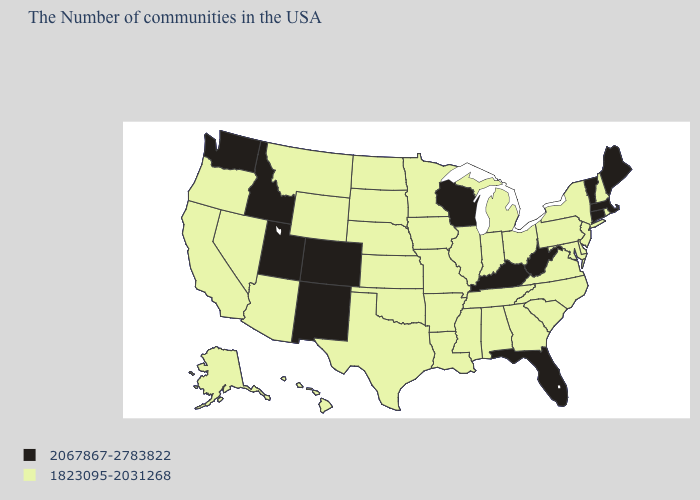What is the lowest value in states that border Washington?
Give a very brief answer. 1823095-2031268. Does Illinois have the same value as Idaho?
Write a very short answer. No. Name the states that have a value in the range 1823095-2031268?
Give a very brief answer. Rhode Island, New Hampshire, New York, New Jersey, Delaware, Maryland, Pennsylvania, Virginia, North Carolina, South Carolina, Ohio, Georgia, Michigan, Indiana, Alabama, Tennessee, Illinois, Mississippi, Louisiana, Missouri, Arkansas, Minnesota, Iowa, Kansas, Nebraska, Oklahoma, Texas, South Dakota, North Dakota, Wyoming, Montana, Arizona, Nevada, California, Oregon, Alaska, Hawaii. What is the value of Florida?
Write a very short answer. 2067867-2783822. How many symbols are there in the legend?
Quick response, please. 2. Name the states that have a value in the range 2067867-2783822?
Short answer required. Maine, Massachusetts, Vermont, Connecticut, West Virginia, Florida, Kentucky, Wisconsin, Colorado, New Mexico, Utah, Idaho, Washington. Does the map have missing data?
Concise answer only. No. Does Ohio have the lowest value in the MidWest?
Concise answer only. Yes. Among the states that border Mississippi , which have the highest value?
Give a very brief answer. Alabama, Tennessee, Louisiana, Arkansas. Among the states that border North Carolina , which have the highest value?
Be succinct. Virginia, South Carolina, Georgia, Tennessee. Name the states that have a value in the range 2067867-2783822?
Write a very short answer. Maine, Massachusetts, Vermont, Connecticut, West Virginia, Florida, Kentucky, Wisconsin, Colorado, New Mexico, Utah, Idaho, Washington. Among the states that border Washington , does Oregon have the highest value?
Be succinct. No. Name the states that have a value in the range 2067867-2783822?
Quick response, please. Maine, Massachusetts, Vermont, Connecticut, West Virginia, Florida, Kentucky, Wisconsin, Colorado, New Mexico, Utah, Idaho, Washington. What is the value of Missouri?
Concise answer only. 1823095-2031268. 